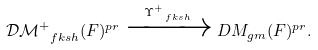<formula> <loc_0><loc_0><loc_500><loc_500>\mathcal { D M } ^ { + } _ { \ f k s h } ( F ) ^ { p r } \xrightarrow { \Upsilon ^ { + } _ { \ f k s h } } D M _ { g m } ( F ) ^ { p r } .</formula> 